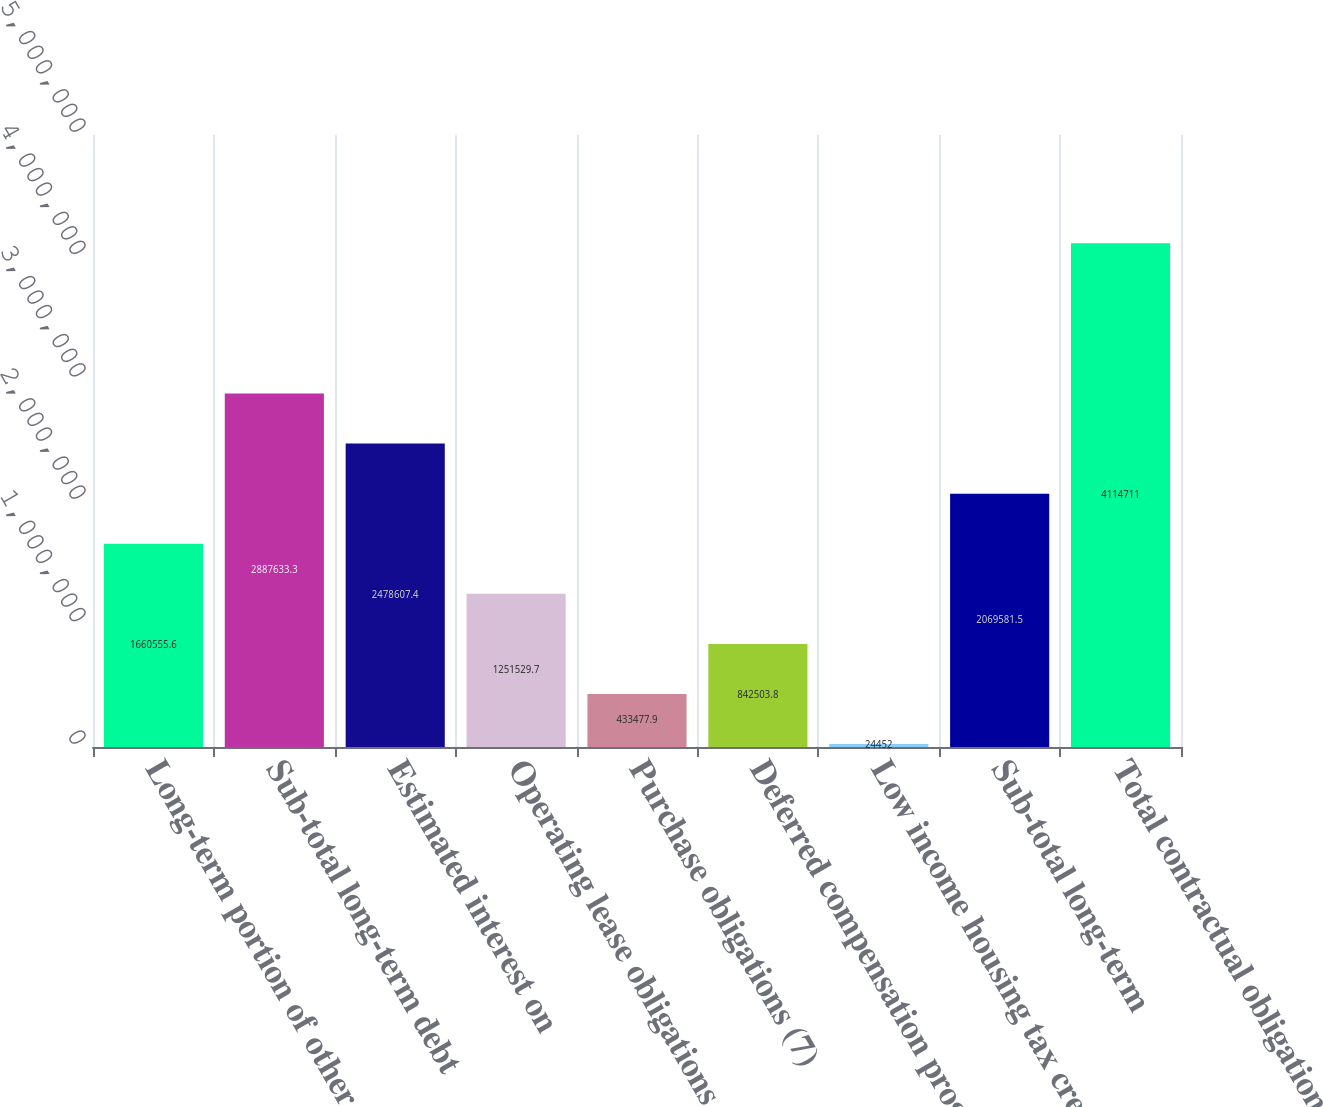Convert chart. <chart><loc_0><loc_0><loc_500><loc_500><bar_chart><fcel>Long-term portion of other<fcel>Sub-total long-term debt<fcel>Estimated interest on<fcel>Operating lease obligations<fcel>Purchase obligations (7)<fcel>Deferred compensation programs<fcel>Low income housing tax credit<fcel>Sub-total long-term<fcel>Total contractual obligations<nl><fcel>1.66056e+06<fcel>2.88763e+06<fcel>2.47861e+06<fcel>1.25153e+06<fcel>433478<fcel>842504<fcel>24452<fcel>2.06958e+06<fcel>4.11471e+06<nl></chart> 